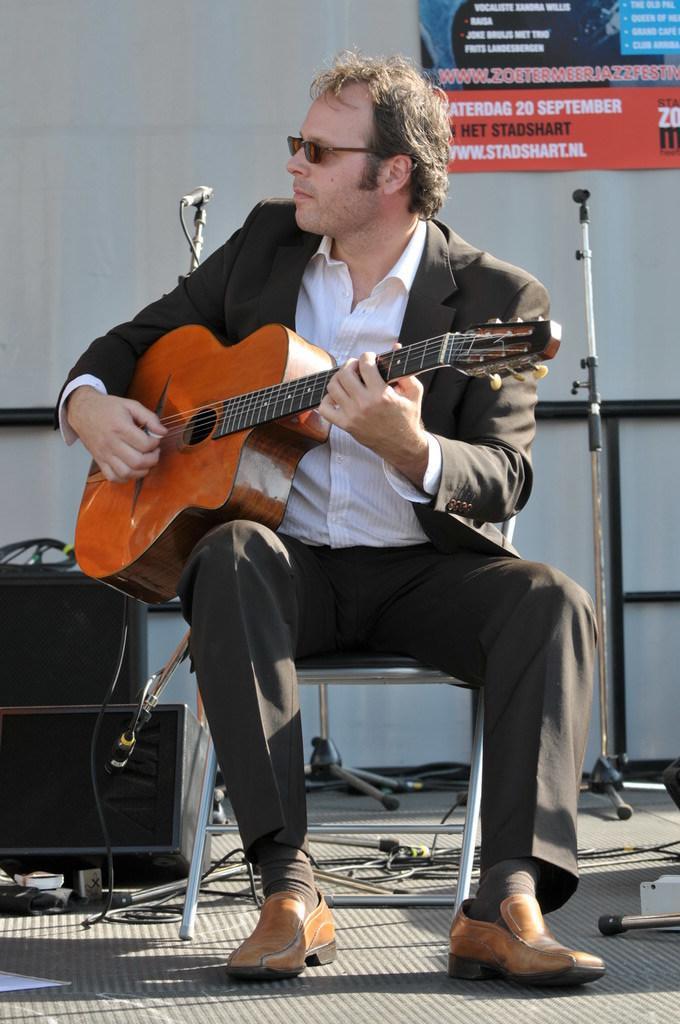Please provide a concise description of this image. In this image a man is sitting on a chair and holding a guitar in his hands and ready to play a music. At the background there is a wall and a poster with a text on it. At the bottom of the image there is a stage. 